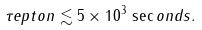<formula> <loc_0><loc_0><loc_500><loc_500>\tau _ { \sl } e p t o n \lesssim 5 \times 1 0 ^ { 3 } \, \sec o n d s .</formula> 